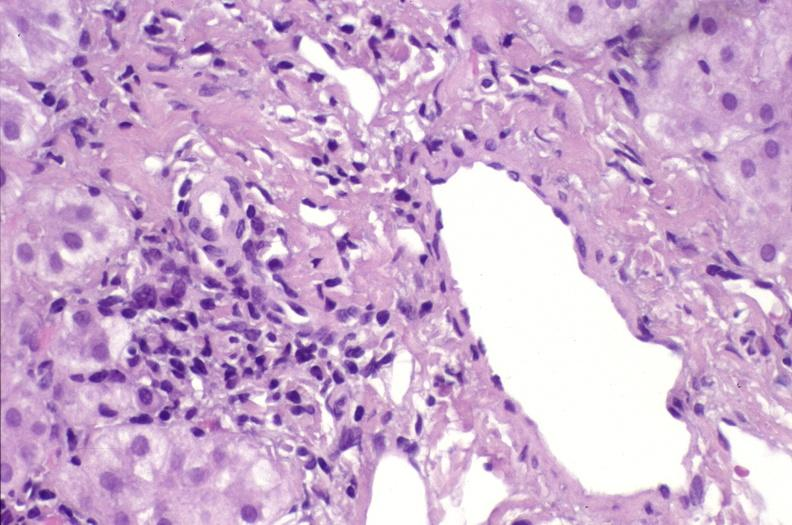s chromophobe adenoma present?
Answer the question using a single word or phrase. No 